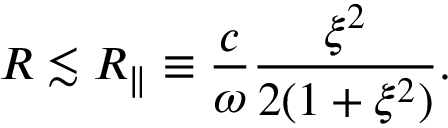<formula> <loc_0><loc_0><loc_500><loc_500>R \lesssim R _ { \| } \equiv \frac { c } { \omega } \frac { \xi ^ { 2 } } { 2 ( 1 + \xi ^ { 2 } ) } .</formula> 